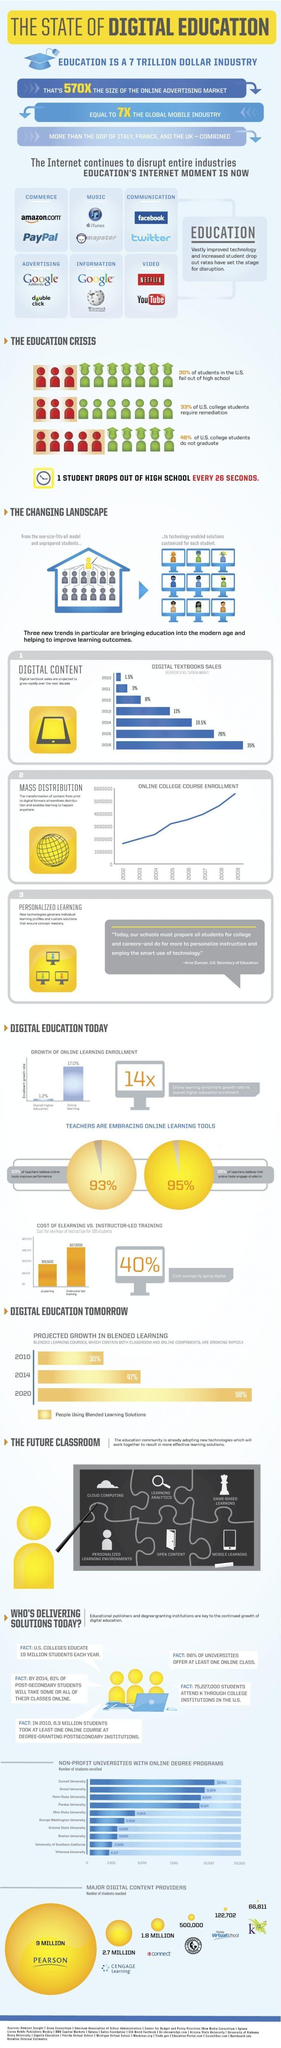Which company has the highest market share in providing digital content ?
Answer the question with a short phrase. Pearson Which company has the second lowest market share in providing digital content ? Florida Virtual School Which are the two most preferred internet tools used for making online payments? Amazon, PayPal How many students use the CEngage learning platform for digital content, 9 million, 2.7 million, or 1.8 million? 2.7 million Which are the two most preferred internet tools used to obtain information? Google, Wikipedia 